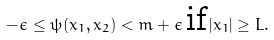Convert formula to latex. <formula><loc_0><loc_0><loc_500><loc_500>- \epsilon \leq \psi ( x _ { 1 } , x _ { 2 } ) < m + \epsilon \, \text {if} \, | x _ { 1 } | \geq L .</formula> 